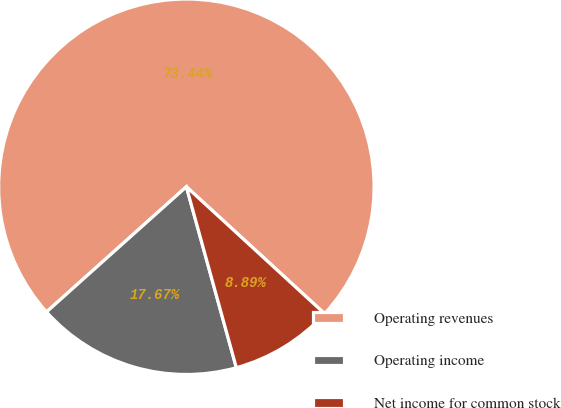Convert chart. <chart><loc_0><loc_0><loc_500><loc_500><pie_chart><fcel>Operating revenues<fcel>Operating income<fcel>Net income for common stock<nl><fcel>73.44%<fcel>17.67%<fcel>8.89%<nl></chart> 